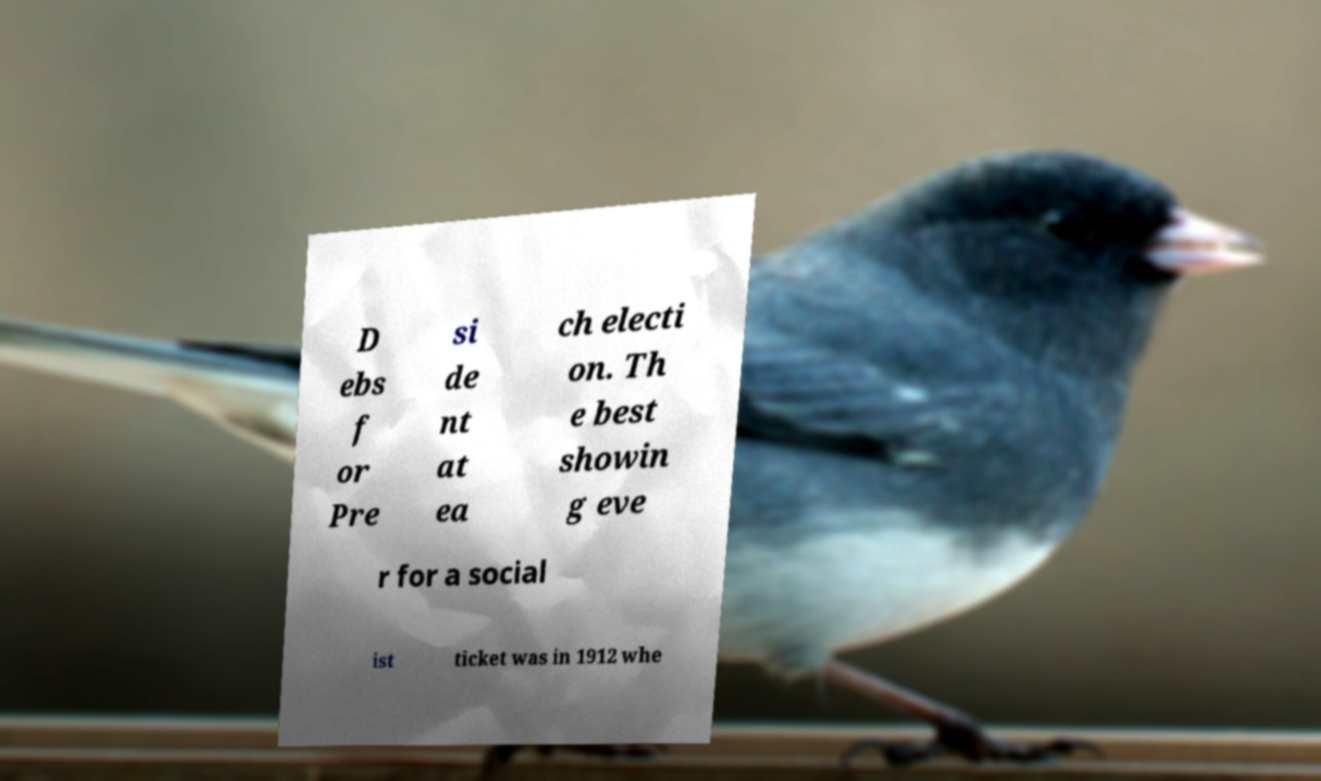Could you extract and type out the text from this image? D ebs f or Pre si de nt at ea ch electi on. Th e best showin g eve r for a social ist ticket was in 1912 whe 